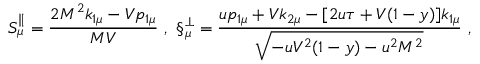Convert formula to latex. <formula><loc_0><loc_0><loc_500><loc_500>S _ { \mu } ^ { \| } = \frac { 2 M ^ { 2 } k _ { 1 \mu } - V p _ { 1 \mu } } { M V } \ , \ \S _ { \mu } ^ { \bot } = \frac { u p _ { 1 \mu } + V k _ { 2 \mu } - [ 2 u \tau + V ( 1 - y ) ] k _ { 1 \mu } } { \sqrt { - u V ^ { 2 } ( 1 - y ) - u ^ { 2 } M ^ { 2 } } } \ ,</formula> 